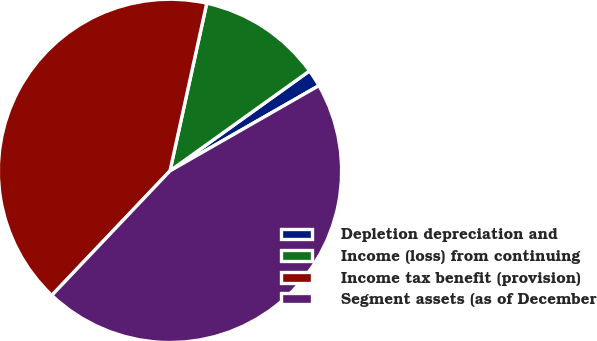<chart> <loc_0><loc_0><loc_500><loc_500><pie_chart><fcel>Depletion depreciation and<fcel>Income (loss) from continuing<fcel>Income tax benefit (provision)<fcel>Segment assets (as of December<nl><fcel>1.62%<fcel>11.67%<fcel>41.35%<fcel>45.36%<nl></chart> 